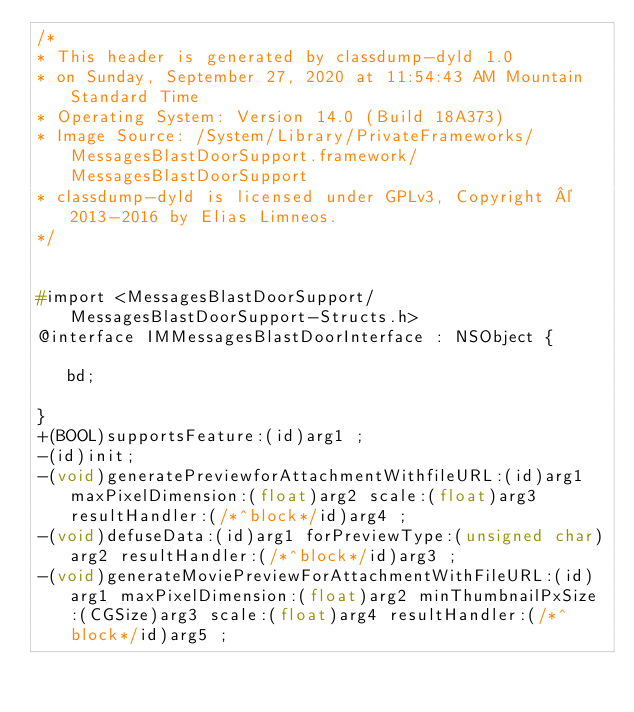Convert code to text. <code><loc_0><loc_0><loc_500><loc_500><_C_>/*
* This header is generated by classdump-dyld 1.0
* on Sunday, September 27, 2020 at 11:54:43 AM Mountain Standard Time
* Operating System: Version 14.0 (Build 18A373)
* Image Source: /System/Library/PrivateFrameworks/MessagesBlastDoorSupport.framework/MessagesBlastDoorSupport
* classdump-dyld is licensed under GPLv3, Copyright © 2013-2016 by Elias Limneos.
*/


#import <MessagesBlastDoorSupport/MessagesBlastDoorSupport-Structs.h>
@interface IMMessagesBlastDoorInterface : NSObject {

	 bd;

}
+(BOOL)supportsFeature:(id)arg1 ;
-(id)init;
-(void)generatePreviewforAttachmentWithfileURL:(id)arg1 maxPixelDimension:(float)arg2 scale:(float)arg3 resultHandler:(/*^block*/id)arg4 ;
-(void)defuseData:(id)arg1 forPreviewType:(unsigned char)arg2 resultHandler:(/*^block*/id)arg3 ;
-(void)generateMoviePreviewForAttachmentWithFileURL:(id)arg1 maxPixelDimension:(float)arg2 minThumbnailPxSize:(CGSize)arg3 scale:(float)arg4 resultHandler:(/*^block*/id)arg5 ;</code> 